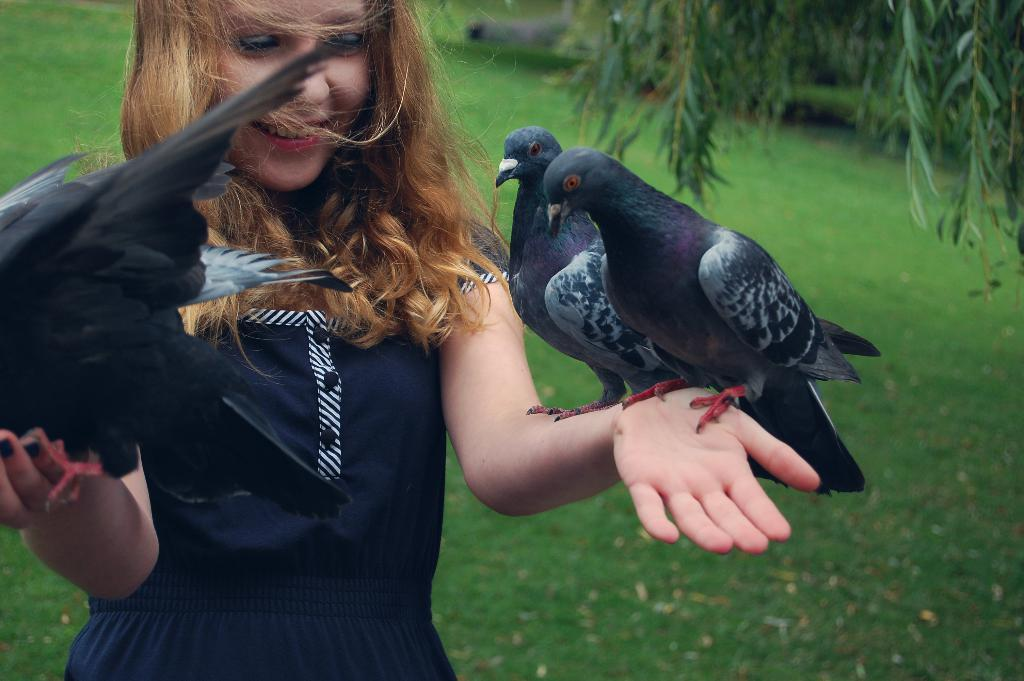Who is the main subject in the image? There is a girl in the image. What is the girl holding in the image? The girl is holding birds. What is the girl's expression in the image? The girl is standing and smiling. What can be seen in the background of the image? There is grass and a tree in the background of the image. What type of tools does the carpenter use in the image? There is no carpenter present in the image, so it is not possible to determine what tools might be used. 